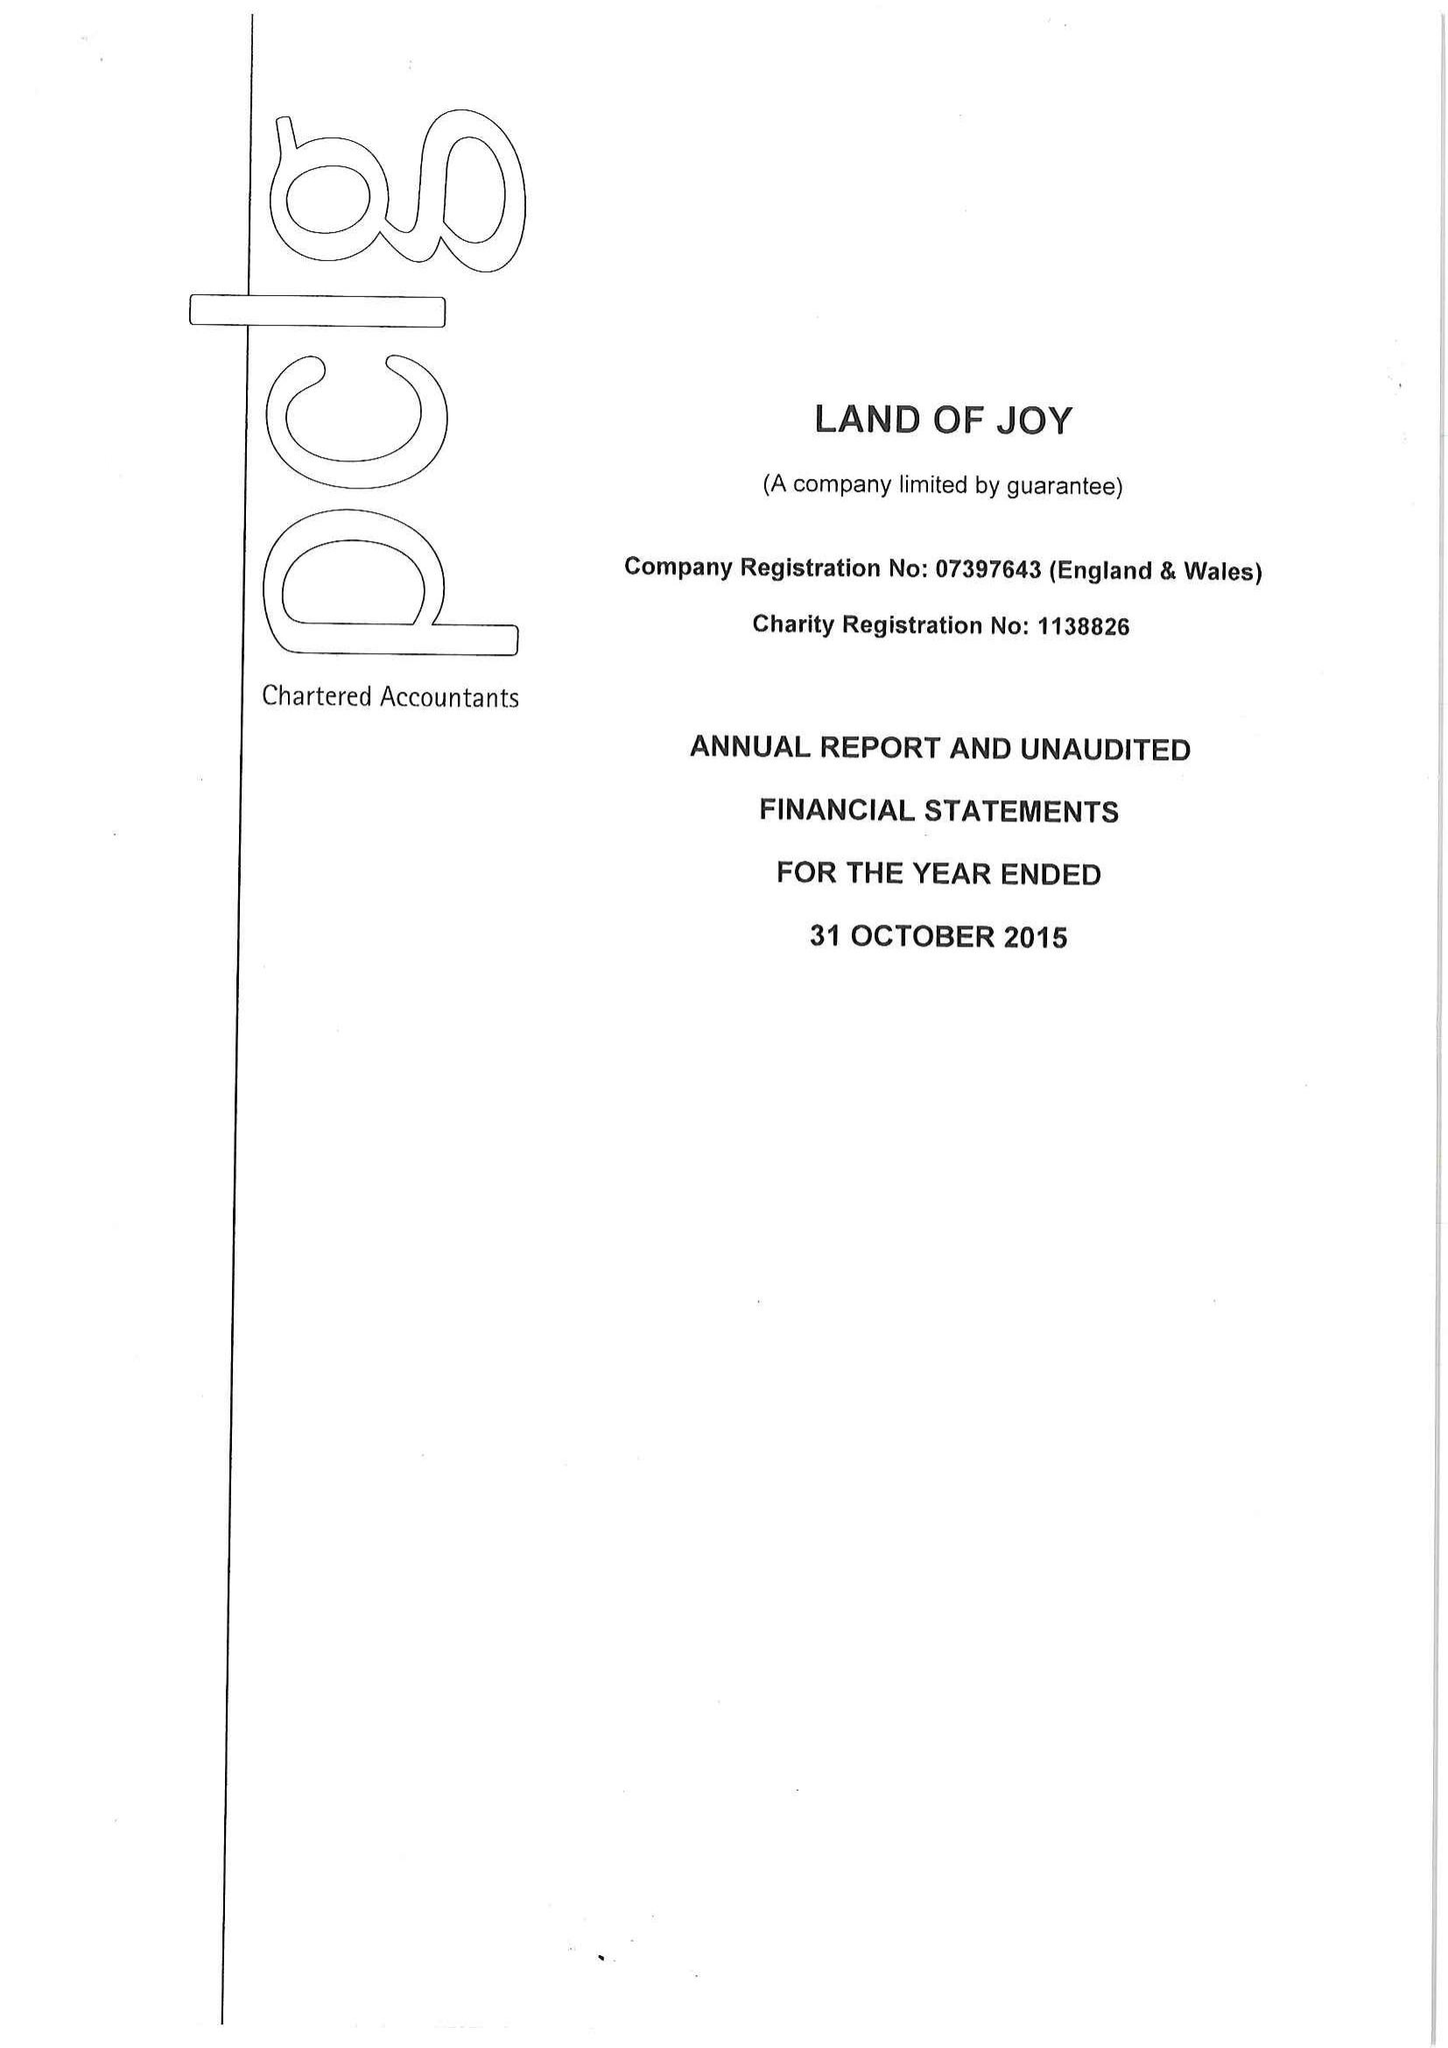What is the value for the income_annually_in_british_pounds?
Answer the question using a single word or phrase. 96553.00 